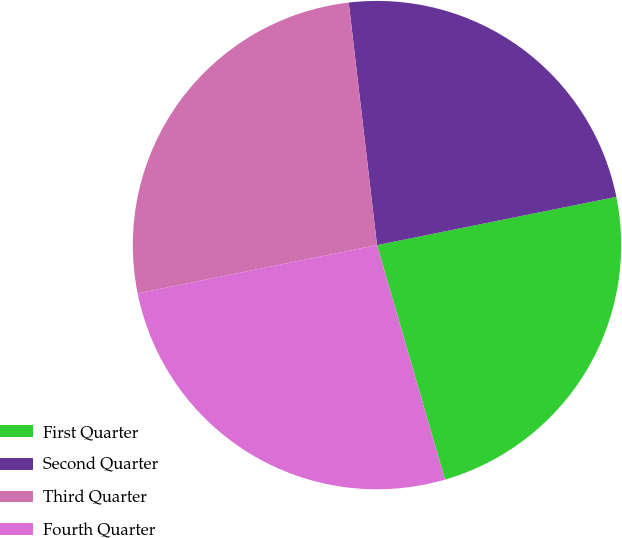Convert chart to OTSL. <chart><loc_0><loc_0><loc_500><loc_500><pie_chart><fcel>First Quarter<fcel>Second Quarter<fcel>Third Quarter<fcel>Fourth Quarter<nl><fcel>23.68%<fcel>23.68%<fcel>26.32%<fcel>26.32%<nl></chart> 